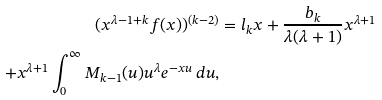<formula> <loc_0><loc_0><loc_500><loc_500>( x ^ { \lambda - 1 + k } f ( x ) ) ^ { ( k - 2 ) } & = l _ { k } x + \frac { b _ { k } } { \lambda ( \lambda + 1 ) } x ^ { \lambda + 1 } \\ + x ^ { \lambda + 1 } \int _ { 0 } ^ { \infty } M _ { k - 1 } ( u ) u ^ { \lambda } e ^ { - x u } \, d u ,</formula> 